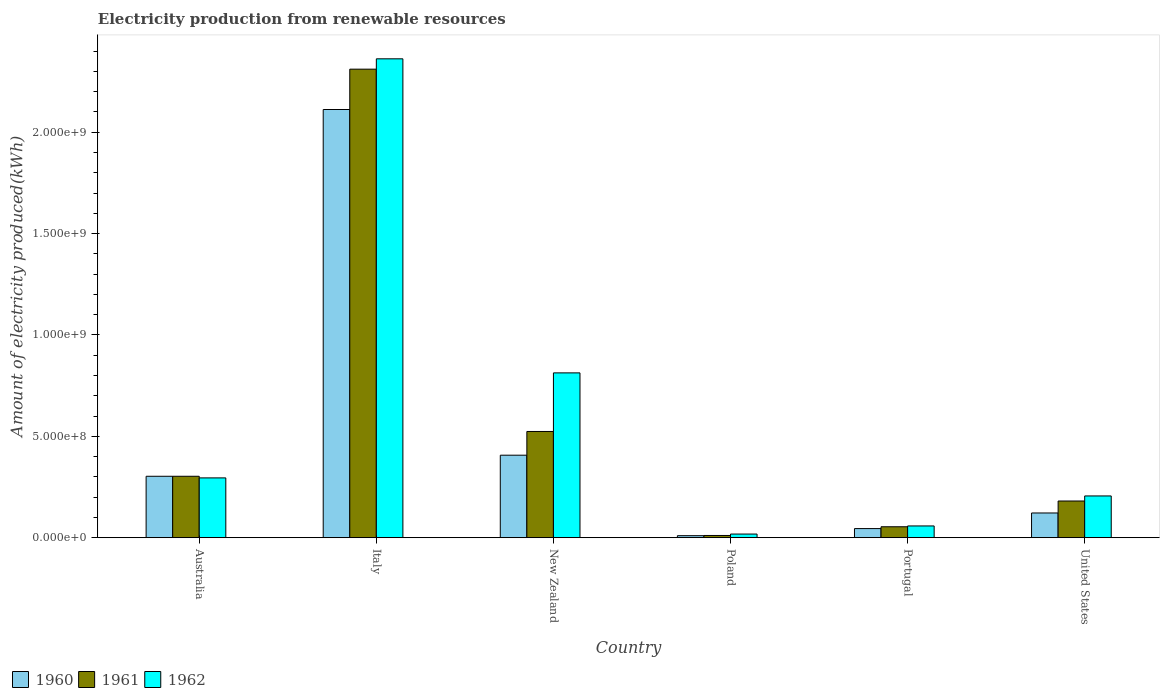How many groups of bars are there?
Keep it short and to the point. 6. Are the number of bars on each tick of the X-axis equal?
Give a very brief answer. Yes. How many bars are there on the 2nd tick from the left?
Give a very brief answer. 3. What is the label of the 6th group of bars from the left?
Provide a short and direct response. United States. What is the amount of electricity produced in 1962 in Poland?
Give a very brief answer. 1.80e+07. Across all countries, what is the maximum amount of electricity produced in 1962?
Your response must be concise. 2.36e+09. In which country was the amount of electricity produced in 1962 minimum?
Your answer should be compact. Poland. What is the total amount of electricity produced in 1961 in the graph?
Your answer should be very brief. 3.38e+09. What is the difference between the amount of electricity produced in 1961 in Italy and that in Poland?
Provide a short and direct response. 2.30e+09. What is the difference between the amount of electricity produced in 1962 in Australia and the amount of electricity produced in 1961 in New Zealand?
Ensure brevity in your answer.  -2.29e+08. What is the average amount of electricity produced in 1960 per country?
Your response must be concise. 5.00e+08. What is the difference between the amount of electricity produced of/in 1962 and amount of electricity produced of/in 1960 in Portugal?
Provide a short and direct response. 1.30e+07. What is the ratio of the amount of electricity produced in 1961 in Italy to that in Portugal?
Give a very brief answer. 42.8. Is the difference between the amount of electricity produced in 1962 in Italy and Poland greater than the difference between the amount of electricity produced in 1960 in Italy and Poland?
Your answer should be very brief. Yes. What is the difference between the highest and the second highest amount of electricity produced in 1961?
Make the answer very short. 1.79e+09. What is the difference between the highest and the lowest amount of electricity produced in 1961?
Offer a very short reply. 2.30e+09. Is the sum of the amount of electricity produced in 1960 in Italy and New Zealand greater than the maximum amount of electricity produced in 1962 across all countries?
Make the answer very short. Yes. Are all the bars in the graph horizontal?
Give a very brief answer. No. Are the values on the major ticks of Y-axis written in scientific E-notation?
Your response must be concise. Yes. Where does the legend appear in the graph?
Make the answer very short. Bottom left. How are the legend labels stacked?
Make the answer very short. Horizontal. What is the title of the graph?
Give a very brief answer. Electricity production from renewable resources. Does "1996" appear as one of the legend labels in the graph?
Offer a very short reply. No. What is the label or title of the X-axis?
Give a very brief answer. Country. What is the label or title of the Y-axis?
Provide a succinct answer. Amount of electricity produced(kWh). What is the Amount of electricity produced(kWh) of 1960 in Australia?
Provide a short and direct response. 3.03e+08. What is the Amount of electricity produced(kWh) of 1961 in Australia?
Give a very brief answer. 3.03e+08. What is the Amount of electricity produced(kWh) of 1962 in Australia?
Your answer should be very brief. 2.95e+08. What is the Amount of electricity produced(kWh) in 1960 in Italy?
Your response must be concise. 2.11e+09. What is the Amount of electricity produced(kWh) of 1961 in Italy?
Offer a terse response. 2.31e+09. What is the Amount of electricity produced(kWh) in 1962 in Italy?
Offer a terse response. 2.36e+09. What is the Amount of electricity produced(kWh) of 1960 in New Zealand?
Provide a succinct answer. 4.07e+08. What is the Amount of electricity produced(kWh) of 1961 in New Zealand?
Your answer should be very brief. 5.24e+08. What is the Amount of electricity produced(kWh) of 1962 in New Zealand?
Offer a terse response. 8.13e+08. What is the Amount of electricity produced(kWh) in 1961 in Poland?
Keep it short and to the point. 1.10e+07. What is the Amount of electricity produced(kWh) in 1962 in Poland?
Make the answer very short. 1.80e+07. What is the Amount of electricity produced(kWh) of 1960 in Portugal?
Make the answer very short. 4.50e+07. What is the Amount of electricity produced(kWh) of 1961 in Portugal?
Your answer should be compact. 5.40e+07. What is the Amount of electricity produced(kWh) in 1962 in Portugal?
Keep it short and to the point. 5.80e+07. What is the Amount of electricity produced(kWh) in 1960 in United States?
Provide a succinct answer. 1.22e+08. What is the Amount of electricity produced(kWh) of 1961 in United States?
Give a very brief answer. 1.81e+08. What is the Amount of electricity produced(kWh) of 1962 in United States?
Provide a short and direct response. 2.06e+08. Across all countries, what is the maximum Amount of electricity produced(kWh) of 1960?
Ensure brevity in your answer.  2.11e+09. Across all countries, what is the maximum Amount of electricity produced(kWh) in 1961?
Make the answer very short. 2.31e+09. Across all countries, what is the maximum Amount of electricity produced(kWh) in 1962?
Provide a short and direct response. 2.36e+09. Across all countries, what is the minimum Amount of electricity produced(kWh) of 1961?
Give a very brief answer. 1.10e+07. Across all countries, what is the minimum Amount of electricity produced(kWh) in 1962?
Your response must be concise. 1.80e+07. What is the total Amount of electricity produced(kWh) of 1960 in the graph?
Provide a short and direct response. 3.00e+09. What is the total Amount of electricity produced(kWh) of 1961 in the graph?
Offer a terse response. 3.38e+09. What is the total Amount of electricity produced(kWh) in 1962 in the graph?
Keep it short and to the point. 3.75e+09. What is the difference between the Amount of electricity produced(kWh) of 1960 in Australia and that in Italy?
Give a very brief answer. -1.81e+09. What is the difference between the Amount of electricity produced(kWh) in 1961 in Australia and that in Italy?
Provide a succinct answer. -2.01e+09. What is the difference between the Amount of electricity produced(kWh) of 1962 in Australia and that in Italy?
Provide a short and direct response. -2.07e+09. What is the difference between the Amount of electricity produced(kWh) of 1960 in Australia and that in New Zealand?
Give a very brief answer. -1.04e+08. What is the difference between the Amount of electricity produced(kWh) of 1961 in Australia and that in New Zealand?
Your answer should be compact. -2.21e+08. What is the difference between the Amount of electricity produced(kWh) in 1962 in Australia and that in New Zealand?
Provide a succinct answer. -5.18e+08. What is the difference between the Amount of electricity produced(kWh) in 1960 in Australia and that in Poland?
Keep it short and to the point. 2.93e+08. What is the difference between the Amount of electricity produced(kWh) in 1961 in Australia and that in Poland?
Your response must be concise. 2.92e+08. What is the difference between the Amount of electricity produced(kWh) of 1962 in Australia and that in Poland?
Offer a terse response. 2.77e+08. What is the difference between the Amount of electricity produced(kWh) in 1960 in Australia and that in Portugal?
Provide a succinct answer. 2.58e+08. What is the difference between the Amount of electricity produced(kWh) in 1961 in Australia and that in Portugal?
Make the answer very short. 2.49e+08. What is the difference between the Amount of electricity produced(kWh) of 1962 in Australia and that in Portugal?
Your answer should be compact. 2.37e+08. What is the difference between the Amount of electricity produced(kWh) in 1960 in Australia and that in United States?
Make the answer very short. 1.81e+08. What is the difference between the Amount of electricity produced(kWh) in 1961 in Australia and that in United States?
Offer a terse response. 1.22e+08. What is the difference between the Amount of electricity produced(kWh) in 1962 in Australia and that in United States?
Ensure brevity in your answer.  8.90e+07. What is the difference between the Amount of electricity produced(kWh) of 1960 in Italy and that in New Zealand?
Your answer should be very brief. 1.70e+09. What is the difference between the Amount of electricity produced(kWh) of 1961 in Italy and that in New Zealand?
Your answer should be very brief. 1.79e+09. What is the difference between the Amount of electricity produced(kWh) of 1962 in Italy and that in New Zealand?
Your answer should be compact. 1.55e+09. What is the difference between the Amount of electricity produced(kWh) in 1960 in Italy and that in Poland?
Make the answer very short. 2.10e+09. What is the difference between the Amount of electricity produced(kWh) in 1961 in Italy and that in Poland?
Provide a succinct answer. 2.30e+09. What is the difference between the Amount of electricity produced(kWh) of 1962 in Italy and that in Poland?
Ensure brevity in your answer.  2.34e+09. What is the difference between the Amount of electricity produced(kWh) of 1960 in Italy and that in Portugal?
Offer a very short reply. 2.07e+09. What is the difference between the Amount of electricity produced(kWh) of 1961 in Italy and that in Portugal?
Keep it short and to the point. 2.26e+09. What is the difference between the Amount of electricity produced(kWh) in 1962 in Italy and that in Portugal?
Ensure brevity in your answer.  2.30e+09. What is the difference between the Amount of electricity produced(kWh) of 1960 in Italy and that in United States?
Provide a short and direct response. 1.99e+09. What is the difference between the Amount of electricity produced(kWh) of 1961 in Italy and that in United States?
Your answer should be compact. 2.13e+09. What is the difference between the Amount of electricity produced(kWh) of 1962 in Italy and that in United States?
Provide a short and direct response. 2.16e+09. What is the difference between the Amount of electricity produced(kWh) of 1960 in New Zealand and that in Poland?
Keep it short and to the point. 3.97e+08. What is the difference between the Amount of electricity produced(kWh) in 1961 in New Zealand and that in Poland?
Give a very brief answer. 5.13e+08. What is the difference between the Amount of electricity produced(kWh) of 1962 in New Zealand and that in Poland?
Keep it short and to the point. 7.95e+08. What is the difference between the Amount of electricity produced(kWh) in 1960 in New Zealand and that in Portugal?
Offer a terse response. 3.62e+08. What is the difference between the Amount of electricity produced(kWh) in 1961 in New Zealand and that in Portugal?
Your answer should be compact. 4.70e+08. What is the difference between the Amount of electricity produced(kWh) in 1962 in New Zealand and that in Portugal?
Provide a succinct answer. 7.55e+08. What is the difference between the Amount of electricity produced(kWh) of 1960 in New Zealand and that in United States?
Make the answer very short. 2.85e+08. What is the difference between the Amount of electricity produced(kWh) in 1961 in New Zealand and that in United States?
Your answer should be compact. 3.43e+08. What is the difference between the Amount of electricity produced(kWh) of 1962 in New Zealand and that in United States?
Make the answer very short. 6.07e+08. What is the difference between the Amount of electricity produced(kWh) in 1960 in Poland and that in Portugal?
Your response must be concise. -3.50e+07. What is the difference between the Amount of electricity produced(kWh) of 1961 in Poland and that in Portugal?
Ensure brevity in your answer.  -4.30e+07. What is the difference between the Amount of electricity produced(kWh) in 1962 in Poland and that in Portugal?
Keep it short and to the point. -4.00e+07. What is the difference between the Amount of electricity produced(kWh) in 1960 in Poland and that in United States?
Provide a succinct answer. -1.12e+08. What is the difference between the Amount of electricity produced(kWh) in 1961 in Poland and that in United States?
Offer a very short reply. -1.70e+08. What is the difference between the Amount of electricity produced(kWh) of 1962 in Poland and that in United States?
Ensure brevity in your answer.  -1.88e+08. What is the difference between the Amount of electricity produced(kWh) of 1960 in Portugal and that in United States?
Make the answer very short. -7.70e+07. What is the difference between the Amount of electricity produced(kWh) in 1961 in Portugal and that in United States?
Provide a succinct answer. -1.27e+08. What is the difference between the Amount of electricity produced(kWh) of 1962 in Portugal and that in United States?
Offer a very short reply. -1.48e+08. What is the difference between the Amount of electricity produced(kWh) of 1960 in Australia and the Amount of electricity produced(kWh) of 1961 in Italy?
Provide a succinct answer. -2.01e+09. What is the difference between the Amount of electricity produced(kWh) of 1960 in Australia and the Amount of electricity produced(kWh) of 1962 in Italy?
Keep it short and to the point. -2.06e+09. What is the difference between the Amount of electricity produced(kWh) of 1961 in Australia and the Amount of electricity produced(kWh) of 1962 in Italy?
Offer a terse response. -2.06e+09. What is the difference between the Amount of electricity produced(kWh) of 1960 in Australia and the Amount of electricity produced(kWh) of 1961 in New Zealand?
Keep it short and to the point. -2.21e+08. What is the difference between the Amount of electricity produced(kWh) of 1960 in Australia and the Amount of electricity produced(kWh) of 1962 in New Zealand?
Your answer should be very brief. -5.10e+08. What is the difference between the Amount of electricity produced(kWh) in 1961 in Australia and the Amount of electricity produced(kWh) in 1962 in New Zealand?
Your answer should be very brief. -5.10e+08. What is the difference between the Amount of electricity produced(kWh) in 1960 in Australia and the Amount of electricity produced(kWh) in 1961 in Poland?
Provide a succinct answer. 2.92e+08. What is the difference between the Amount of electricity produced(kWh) of 1960 in Australia and the Amount of electricity produced(kWh) of 1962 in Poland?
Give a very brief answer. 2.85e+08. What is the difference between the Amount of electricity produced(kWh) of 1961 in Australia and the Amount of electricity produced(kWh) of 1962 in Poland?
Provide a succinct answer. 2.85e+08. What is the difference between the Amount of electricity produced(kWh) in 1960 in Australia and the Amount of electricity produced(kWh) in 1961 in Portugal?
Offer a very short reply. 2.49e+08. What is the difference between the Amount of electricity produced(kWh) of 1960 in Australia and the Amount of electricity produced(kWh) of 1962 in Portugal?
Offer a terse response. 2.45e+08. What is the difference between the Amount of electricity produced(kWh) in 1961 in Australia and the Amount of electricity produced(kWh) in 1962 in Portugal?
Keep it short and to the point. 2.45e+08. What is the difference between the Amount of electricity produced(kWh) in 1960 in Australia and the Amount of electricity produced(kWh) in 1961 in United States?
Offer a very short reply. 1.22e+08. What is the difference between the Amount of electricity produced(kWh) of 1960 in Australia and the Amount of electricity produced(kWh) of 1962 in United States?
Keep it short and to the point. 9.70e+07. What is the difference between the Amount of electricity produced(kWh) in 1961 in Australia and the Amount of electricity produced(kWh) in 1962 in United States?
Give a very brief answer. 9.70e+07. What is the difference between the Amount of electricity produced(kWh) of 1960 in Italy and the Amount of electricity produced(kWh) of 1961 in New Zealand?
Your answer should be compact. 1.59e+09. What is the difference between the Amount of electricity produced(kWh) in 1960 in Italy and the Amount of electricity produced(kWh) in 1962 in New Zealand?
Make the answer very short. 1.30e+09. What is the difference between the Amount of electricity produced(kWh) of 1961 in Italy and the Amount of electricity produced(kWh) of 1962 in New Zealand?
Make the answer very short. 1.50e+09. What is the difference between the Amount of electricity produced(kWh) in 1960 in Italy and the Amount of electricity produced(kWh) in 1961 in Poland?
Your response must be concise. 2.10e+09. What is the difference between the Amount of electricity produced(kWh) of 1960 in Italy and the Amount of electricity produced(kWh) of 1962 in Poland?
Provide a short and direct response. 2.09e+09. What is the difference between the Amount of electricity produced(kWh) in 1961 in Italy and the Amount of electricity produced(kWh) in 1962 in Poland?
Your answer should be compact. 2.29e+09. What is the difference between the Amount of electricity produced(kWh) of 1960 in Italy and the Amount of electricity produced(kWh) of 1961 in Portugal?
Offer a very short reply. 2.06e+09. What is the difference between the Amount of electricity produced(kWh) in 1960 in Italy and the Amount of electricity produced(kWh) in 1962 in Portugal?
Offer a terse response. 2.05e+09. What is the difference between the Amount of electricity produced(kWh) in 1961 in Italy and the Amount of electricity produced(kWh) in 1962 in Portugal?
Your answer should be compact. 2.25e+09. What is the difference between the Amount of electricity produced(kWh) of 1960 in Italy and the Amount of electricity produced(kWh) of 1961 in United States?
Provide a succinct answer. 1.93e+09. What is the difference between the Amount of electricity produced(kWh) in 1960 in Italy and the Amount of electricity produced(kWh) in 1962 in United States?
Your answer should be compact. 1.91e+09. What is the difference between the Amount of electricity produced(kWh) of 1961 in Italy and the Amount of electricity produced(kWh) of 1962 in United States?
Provide a succinct answer. 2.10e+09. What is the difference between the Amount of electricity produced(kWh) in 1960 in New Zealand and the Amount of electricity produced(kWh) in 1961 in Poland?
Provide a succinct answer. 3.96e+08. What is the difference between the Amount of electricity produced(kWh) in 1960 in New Zealand and the Amount of electricity produced(kWh) in 1962 in Poland?
Provide a short and direct response. 3.89e+08. What is the difference between the Amount of electricity produced(kWh) of 1961 in New Zealand and the Amount of electricity produced(kWh) of 1962 in Poland?
Give a very brief answer. 5.06e+08. What is the difference between the Amount of electricity produced(kWh) in 1960 in New Zealand and the Amount of electricity produced(kWh) in 1961 in Portugal?
Your answer should be very brief. 3.53e+08. What is the difference between the Amount of electricity produced(kWh) in 1960 in New Zealand and the Amount of electricity produced(kWh) in 1962 in Portugal?
Offer a very short reply. 3.49e+08. What is the difference between the Amount of electricity produced(kWh) of 1961 in New Zealand and the Amount of electricity produced(kWh) of 1962 in Portugal?
Your response must be concise. 4.66e+08. What is the difference between the Amount of electricity produced(kWh) of 1960 in New Zealand and the Amount of electricity produced(kWh) of 1961 in United States?
Make the answer very short. 2.26e+08. What is the difference between the Amount of electricity produced(kWh) in 1960 in New Zealand and the Amount of electricity produced(kWh) in 1962 in United States?
Your response must be concise. 2.01e+08. What is the difference between the Amount of electricity produced(kWh) of 1961 in New Zealand and the Amount of electricity produced(kWh) of 1962 in United States?
Keep it short and to the point. 3.18e+08. What is the difference between the Amount of electricity produced(kWh) of 1960 in Poland and the Amount of electricity produced(kWh) of 1961 in Portugal?
Offer a terse response. -4.40e+07. What is the difference between the Amount of electricity produced(kWh) of 1960 in Poland and the Amount of electricity produced(kWh) of 1962 in Portugal?
Keep it short and to the point. -4.80e+07. What is the difference between the Amount of electricity produced(kWh) of 1961 in Poland and the Amount of electricity produced(kWh) of 1962 in Portugal?
Give a very brief answer. -4.70e+07. What is the difference between the Amount of electricity produced(kWh) of 1960 in Poland and the Amount of electricity produced(kWh) of 1961 in United States?
Make the answer very short. -1.71e+08. What is the difference between the Amount of electricity produced(kWh) of 1960 in Poland and the Amount of electricity produced(kWh) of 1962 in United States?
Make the answer very short. -1.96e+08. What is the difference between the Amount of electricity produced(kWh) of 1961 in Poland and the Amount of electricity produced(kWh) of 1962 in United States?
Provide a short and direct response. -1.95e+08. What is the difference between the Amount of electricity produced(kWh) in 1960 in Portugal and the Amount of electricity produced(kWh) in 1961 in United States?
Provide a short and direct response. -1.36e+08. What is the difference between the Amount of electricity produced(kWh) of 1960 in Portugal and the Amount of electricity produced(kWh) of 1962 in United States?
Give a very brief answer. -1.61e+08. What is the difference between the Amount of electricity produced(kWh) in 1961 in Portugal and the Amount of electricity produced(kWh) in 1962 in United States?
Provide a short and direct response. -1.52e+08. What is the average Amount of electricity produced(kWh) of 1960 per country?
Offer a very short reply. 5.00e+08. What is the average Amount of electricity produced(kWh) of 1961 per country?
Your response must be concise. 5.64e+08. What is the average Amount of electricity produced(kWh) of 1962 per country?
Keep it short and to the point. 6.25e+08. What is the difference between the Amount of electricity produced(kWh) of 1960 and Amount of electricity produced(kWh) of 1961 in Australia?
Your answer should be compact. 0. What is the difference between the Amount of electricity produced(kWh) of 1961 and Amount of electricity produced(kWh) of 1962 in Australia?
Offer a very short reply. 8.00e+06. What is the difference between the Amount of electricity produced(kWh) of 1960 and Amount of electricity produced(kWh) of 1961 in Italy?
Your answer should be very brief. -1.99e+08. What is the difference between the Amount of electricity produced(kWh) in 1960 and Amount of electricity produced(kWh) in 1962 in Italy?
Ensure brevity in your answer.  -2.50e+08. What is the difference between the Amount of electricity produced(kWh) of 1961 and Amount of electricity produced(kWh) of 1962 in Italy?
Your response must be concise. -5.10e+07. What is the difference between the Amount of electricity produced(kWh) in 1960 and Amount of electricity produced(kWh) in 1961 in New Zealand?
Ensure brevity in your answer.  -1.17e+08. What is the difference between the Amount of electricity produced(kWh) in 1960 and Amount of electricity produced(kWh) in 1962 in New Zealand?
Your answer should be very brief. -4.06e+08. What is the difference between the Amount of electricity produced(kWh) of 1961 and Amount of electricity produced(kWh) of 1962 in New Zealand?
Make the answer very short. -2.89e+08. What is the difference between the Amount of electricity produced(kWh) in 1960 and Amount of electricity produced(kWh) in 1961 in Poland?
Provide a short and direct response. -1.00e+06. What is the difference between the Amount of electricity produced(kWh) of 1960 and Amount of electricity produced(kWh) of 1962 in Poland?
Your answer should be very brief. -8.00e+06. What is the difference between the Amount of electricity produced(kWh) of 1961 and Amount of electricity produced(kWh) of 1962 in Poland?
Ensure brevity in your answer.  -7.00e+06. What is the difference between the Amount of electricity produced(kWh) of 1960 and Amount of electricity produced(kWh) of 1961 in Portugal?
Make the answer very short. -9.00e+06. What is the difference between the Amount of electricity produced(kWh) of 1960 and Amount of electricity produced(kWh) of 1962 in Portugal?
Offer a terse response. -1.30e+07. What is the difference between the Amount of electricity produced(kWh) of 1961 and Amount of electricity produced(kWh) of 1962 in Portugal?
Keep it short and to the point. -4.00e+06. What is the difference between the Amount of electricity produced(kWh) of 1960 and Amount of electricity produced(kWh) of 1961 in United States?
Provide a short and direct response. -5.90e+07. What is the difference between the Amount of electricity produced(kWh) in 1960 and Amount of electricity produced(kWh) in 1962 in United States?
Make the answer very short. -8.40e+07. What is the difference between the Amount of electricity produced(kWh) in 1961 and Amount of electricity produced(kWh) in 1962 in United States?
Provide a short and direct response. -2.50e+07. What is the ratio of the Amount of electricity produced(kWh) of 1960 in Australia to that in Italy?
Provide a short and direct response. 0.14. What is the ratio of the Amount of electricity produced(kWh) in 1961 in Australia to that in Italy?
Keep it short and to the point. 0.13. What is the ratio of the Amount of electricity produced(kWh) in 1962 in Australia to that in Italy?
Offer a terse response. 0.12. What is the ratio of the Amount of electricity produced(kWh) of 1960 in Australia to that in New Zealand?
Give a very brief answer. 0.74. What is the ratio of the Amount of electricity produced(kWh) of 1961 in Australia to that in New Zealand?
Provide a short and direct response. 0.58. What is the ratio of the Amount of electricity produced(kWh) of 1962 in Australia to that in New Zealand?
Your answer should be compact. 0.36. What is the ratio of the Amount of electricity produced(kWh) in 1960 in Australia to that in Poland?
Your answer should be very brief. 30.3. What is the ratio of the Amount of electricity produced(kWh) of 1961 in Australia to that in Poland?
Your answer should be very brief. 27.55. What is the ratio of the Amount of electricity produced(kWh) of 1962 in Australia to that in Poland?
Ensure brevity in your answer.  16.39. What is the ratio of the Amount of electricity produced(kWh) in 1960 in Australia to that in Portugal?
Offer a terse response. 6.73. What is the ratio of the Amount of electricity produced(kWh) in 1961 in Australia to that in Portugal?
Give a very brief answer. 5.61. What is the ratio of the Amount of electricity produced(kWh) of 1962 in Australia to that in Portugal?
Provide a short and direct response. 5.09. What is the ratio of the Amount of electricity produced(kWh) of 1960 in Australia to that in United States?
Provide a succinct answer. 2.48. What is the ratio of the Amount of electricity produced(kWh) in 1961 in Australia to that in United States?
Give a very brief answer. 1.67. What is the ratio of the Amount of electricity produced(kWh) of 1962 in Australia to that in United States?
Give a very brief answer. 1.43. What is the ratio of the Amount of electricity produced(kWh) in 1960 in Italy to that in New Zealand?
Your response must be concise. 5.19. What is the ratio of the Amount of electricity produced(kWh) in 1961 in Italy to that in New Zealand?
Keep it short and to the point. 4.41. What is the ratio of the Amount of electricity produced(kWh) in 1962 in Italy to that in New Zealand?
Give a very brief answer. 2.91. What is the ratio of the Amount of electricity produced(kWh) in 1960 in Italy to that in Poland?
Make the answer very short. 211.2. What is the ratio of the Amount of electricity produced(kWh) in 1961 in Italy to that in Poland?
Provide a succinct answer. 210.09. What is the ratio of the Amount of electricity produced(kWh) in 1962 in Italy to that in Poland?
Your answer should be very brief. 131.22. What is the ratio of the Amount of electricity produced(kWh) of 1960 in Italy to that in Portugal?
Offer a very short reply. 46.93. What is the ratio of the Amount of electricity produced(kWh) in 1961 in Italy to that in Portugal?
Your response must be concise. 42.8. What is the ratio of the Amount of electricity produced(kWh) in 1962 in Italy to that in Portugal?
Give a very brief answer. 40.72. What is the ratio of the Amount of electricity produced(kWh) in 1960 in Italy to that in United States?
Your answer should be very brief. 17.31. What is the ratio of the Amount of electricity produced(kWh) in 1961 in Italy to that in United States?
Provide a succinct answer. 12.77. What is the ratio of the Amount of electricity produced(kWh) in 1962 in Italy to that in United States?
Ensure brevity in your answer.  11.47. What is the ratio of the Amount of electricity produced(kWh) of 1960 in New Zealand to that in Poland?
Your response must be concise. 40.7. What is the ratio of the Amount of electricity produced(kWh) of 1961 in New Zealand to that in Poland?
Ensure brevity in your answer.  47.64. What is the ratio of the Amount of electricity produced(kWh) of 1962 in New Zealand to that in Poland?
Ensure brevity in your answer.  45.17. What is the ratio of the Amount of electricity produced(kWh) in 1960 in New Zealand to that in Portugal?
Offer a very short reply. 9.04. What is the ratio of the Amount of electricity produced(kWh) in 1961 in New Zealand to that in Portugal?
Offer a terse response. 9.7. What is the ratio of the Amount of electricity produced(kWh) in 1962 in New Zealand to that in Portugal?
Your answer should be very brief. 14.02. What is the ratio of the Amount of electricity produced(kWh) of 1960 in New Zealand to that in United States?
Your answer should be very brief. 3.34. What is the ratio of the Amount of electricity produced(kWh) of 1961 in New Zealand to that in United States?
Offer a very short reply. 2.9. What is the ratio of the Amount of electricity produced(kWh) of 1962 in New Zealand to that in United States?
Your answer should be very brief. 3.95. What is the ratio of the Amount of electricity produced(kWh) of 1960 in Poland to that in Portugal?
Provide a short and direct response. 0.22. What is the ratio of the Amount of electricity produced(kWh) in 1961 in Poland to that in Portugal?
Offer a very short reply. 0.2. What is the ratio of the Amount of electricity produced(kWh) of 1962 in Poland to that in Portugal?
Offer a very short reply. 0.31. What is the ratio of the Amount of electricity produced(kWh) of 1960 in Poland to that in United States?
Provide a succinct answer. 0.08. What is the ratio of the Amount of electricity produced(kWh) of 1961 in Poland to that in United States?
Give a very brief answer. 0.06. What is the ratio of the Amount of electricity produced(kWh) of 1962 in Poland to that in United States?
Your response must be concise. 0.09. What is the ratio of the Amount of electricity produced(kWh) in 1960 in Portugal to that in United States?
Your response must be concise. 0.37. What is the ratio of the Amount of electricity produced(kWh) of 1961 in Portugal to that in United States?
Give a very brief answer. 0.3. What is the ratio of the Amount of electricity produced(kWh) in 1962 in Portugal to that in United States?
Offer a very short reply. 0.28. What is the difference between the highest and the second highest Amount of electricity produced(kWh) in 1960?
Offer a very short reply. 1.70e+09. What is the difference between the highest and the second highest Amount of electricity produced(kWh) in 1961?
Offer a very short reply. 1.79e+09. What is the difference between the highest and the second highest Amount of electricity produced(kWh) of 1962?
Your answer should be very brief. 1.55e+09. What is the difference between the highest and the lowest Amount of electricity produced(kWh) of 1960?
Provide a succinct answer. 2.10e+09. What is the difference between the highest and the lowest Amount of electricity produced(kWh) in 1961?
Your answer should be very brief. 2.30e+09. What is the difference between the highest and the lowest Amount of electricity produced(kWh) of 1962?
Make the answer very short. 2.34e+09. 